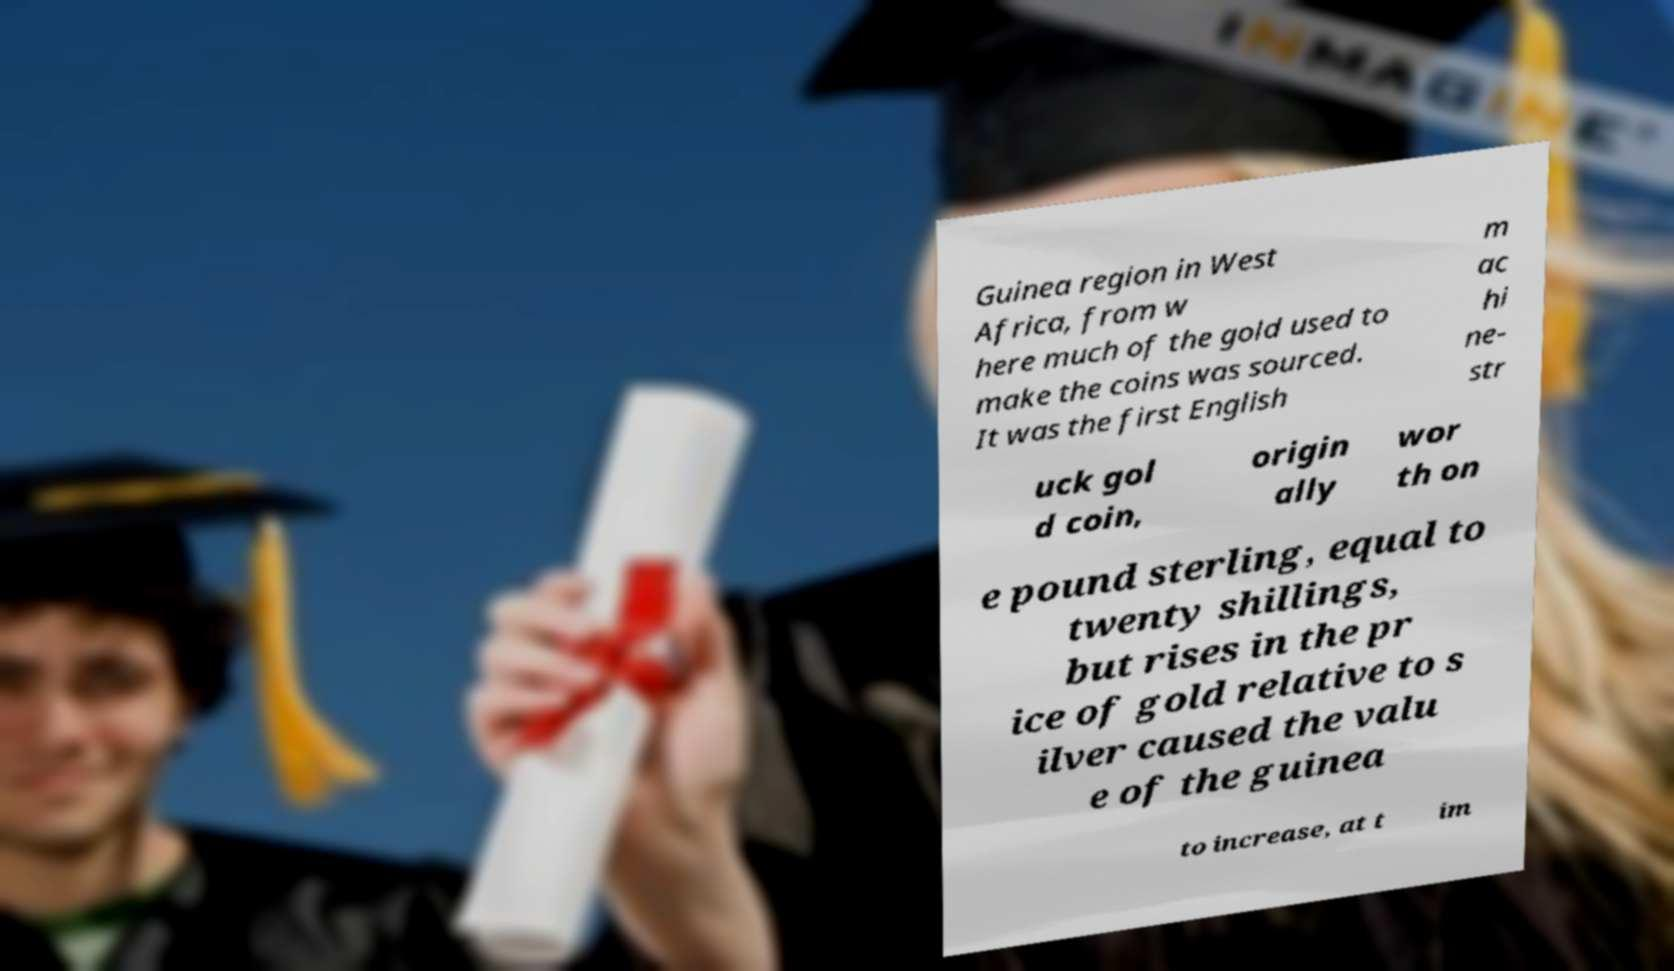Could you extract and type out the text from this image? Guinea region in West Africa, from w here much of the gold used to make the coins was sourced. It was the first English m ac hi ne- str uck gol d coin, origin ally wor th on e pound sterling, equal to twenty shillings, but rises in the pr ice of gold relative to s ilver caused the valu e of the guinea to increase, at t im 